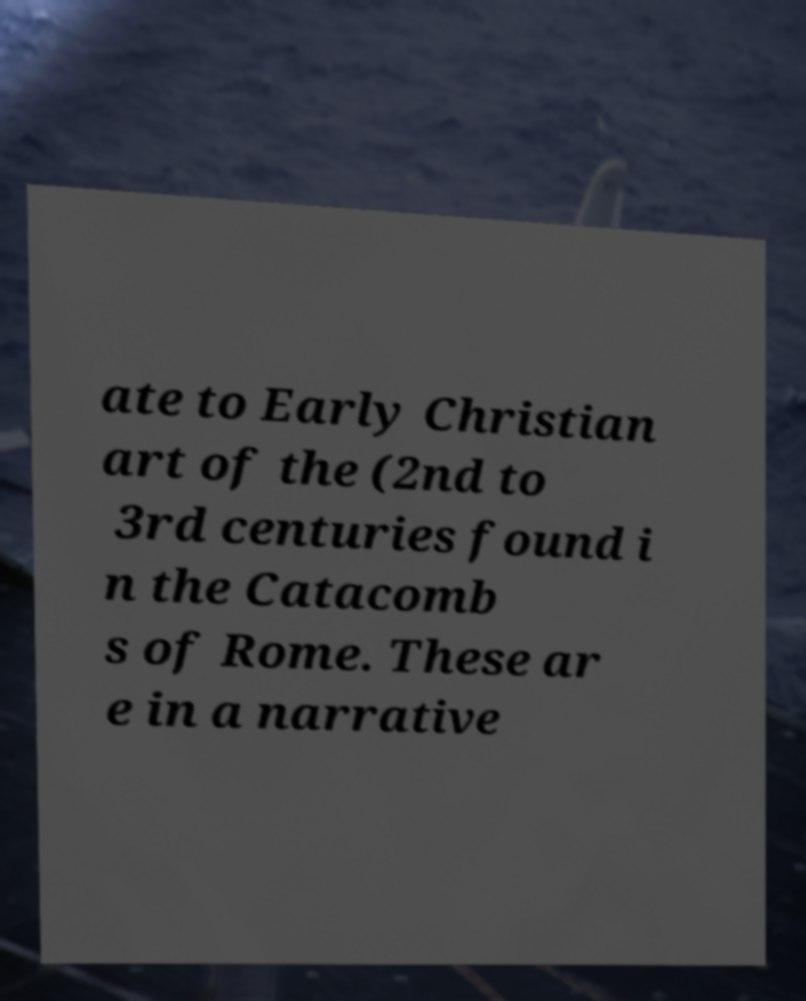What messages or text are displayed in this image? I need them in a readable, typed format. ate to Early Christian art of the (2nd to 3rd centuries found i n the Catacomb s of Rome. These ar e in a narrative 